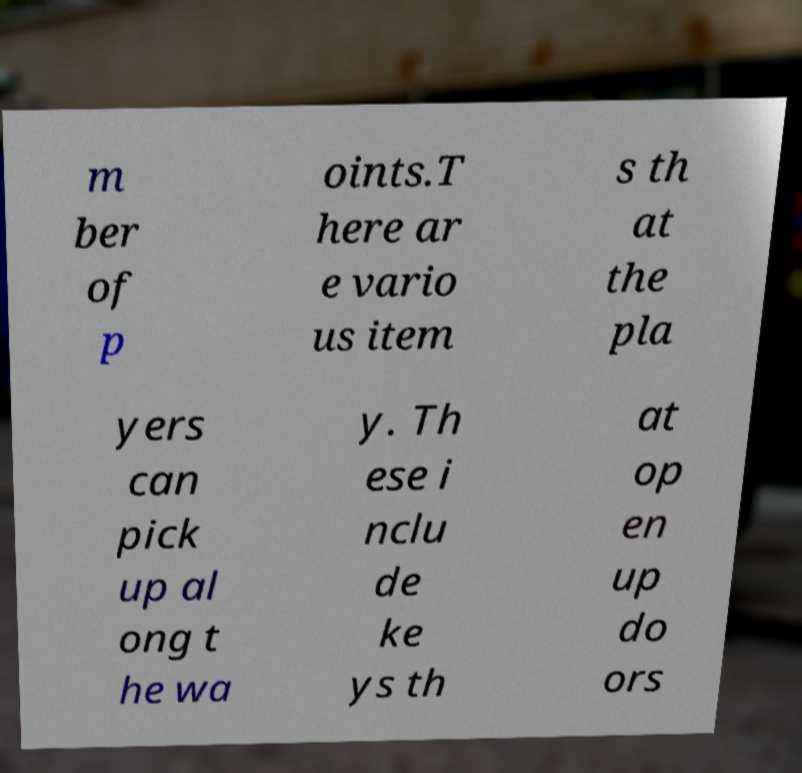Could you assist in decoding the text presented in this image and type it out clearly? m ber of p oints.T here ar e vario us item s th at the pla yers can pick up al ong t he wa y. Th ese i nclu de ke ys th at op en up do ors 